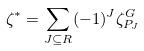Convert formula to latex. <formula><loc_0><loc_0><loc_500><loc_500>\zeta ^ { * } = \sum _ { J \subseteq R } ( - 1 ) ^ { J } \zeta _ { P _ { J } } ^ { G }</formula> 